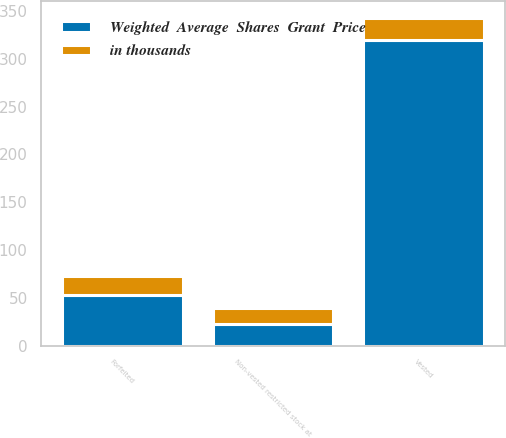Convert chart to OTSL. <chart><loc_0><loc_0><loc_500><loc_500><stacked_bar_chart><ecel><fcel>Non-vested restricted stock at<fcel>Vested<fcel>Forfeited<nl><fcel>Weighted  Average  Shares  Grant  Price<fcel>23.03<fcel>320<fcel>53<nl><fcel>in thousands<fcel>16.83<fcel>22.69<fcel>20.17<nl></chart> 